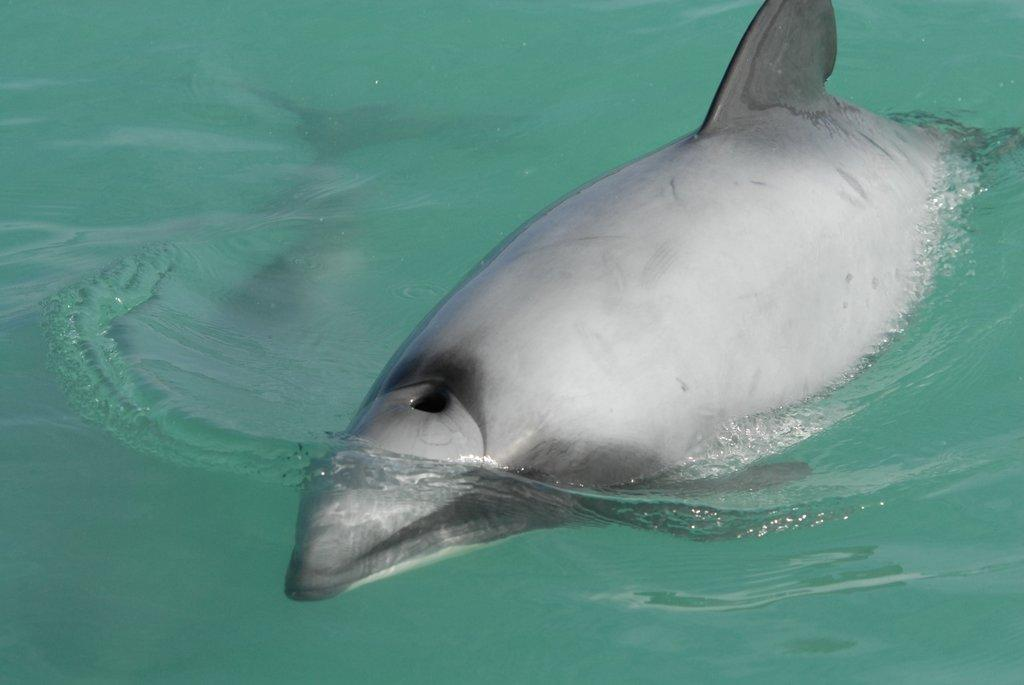What animal is in the image? There is a dolphin in the image. Where is the dolphin located? The dolphin is in the water. What type of net can be seen in the image? There is no net present in the image; it features a dolphin in the water. What type of corn is being used to feed the dolphin in the image? There is no corn or feeding activity depicted in the image; it simply shows a dolphin in the water. 